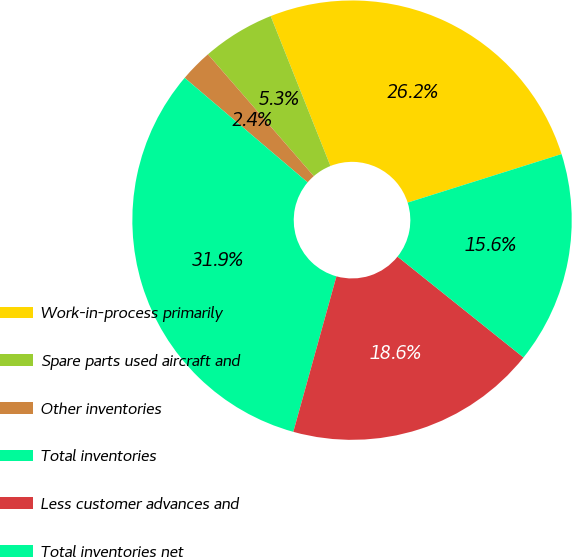Convert chart to OTSL. <chart><loc_0><loc_0><loc_500><loc_500><pie_chart><fcel>Work-in-process primarily<fcel>Spare parts used aircraft and<fcel>Other inventories<fcel>Total inventories<fcel>Less customer advances and<fcel>Total inventories net<nl><fcel>26.18%<fcel>5.35%<fcel>2.4%<fcel>31.91%<fcel>18.56%<fcel>15.61%<nl></chart> 